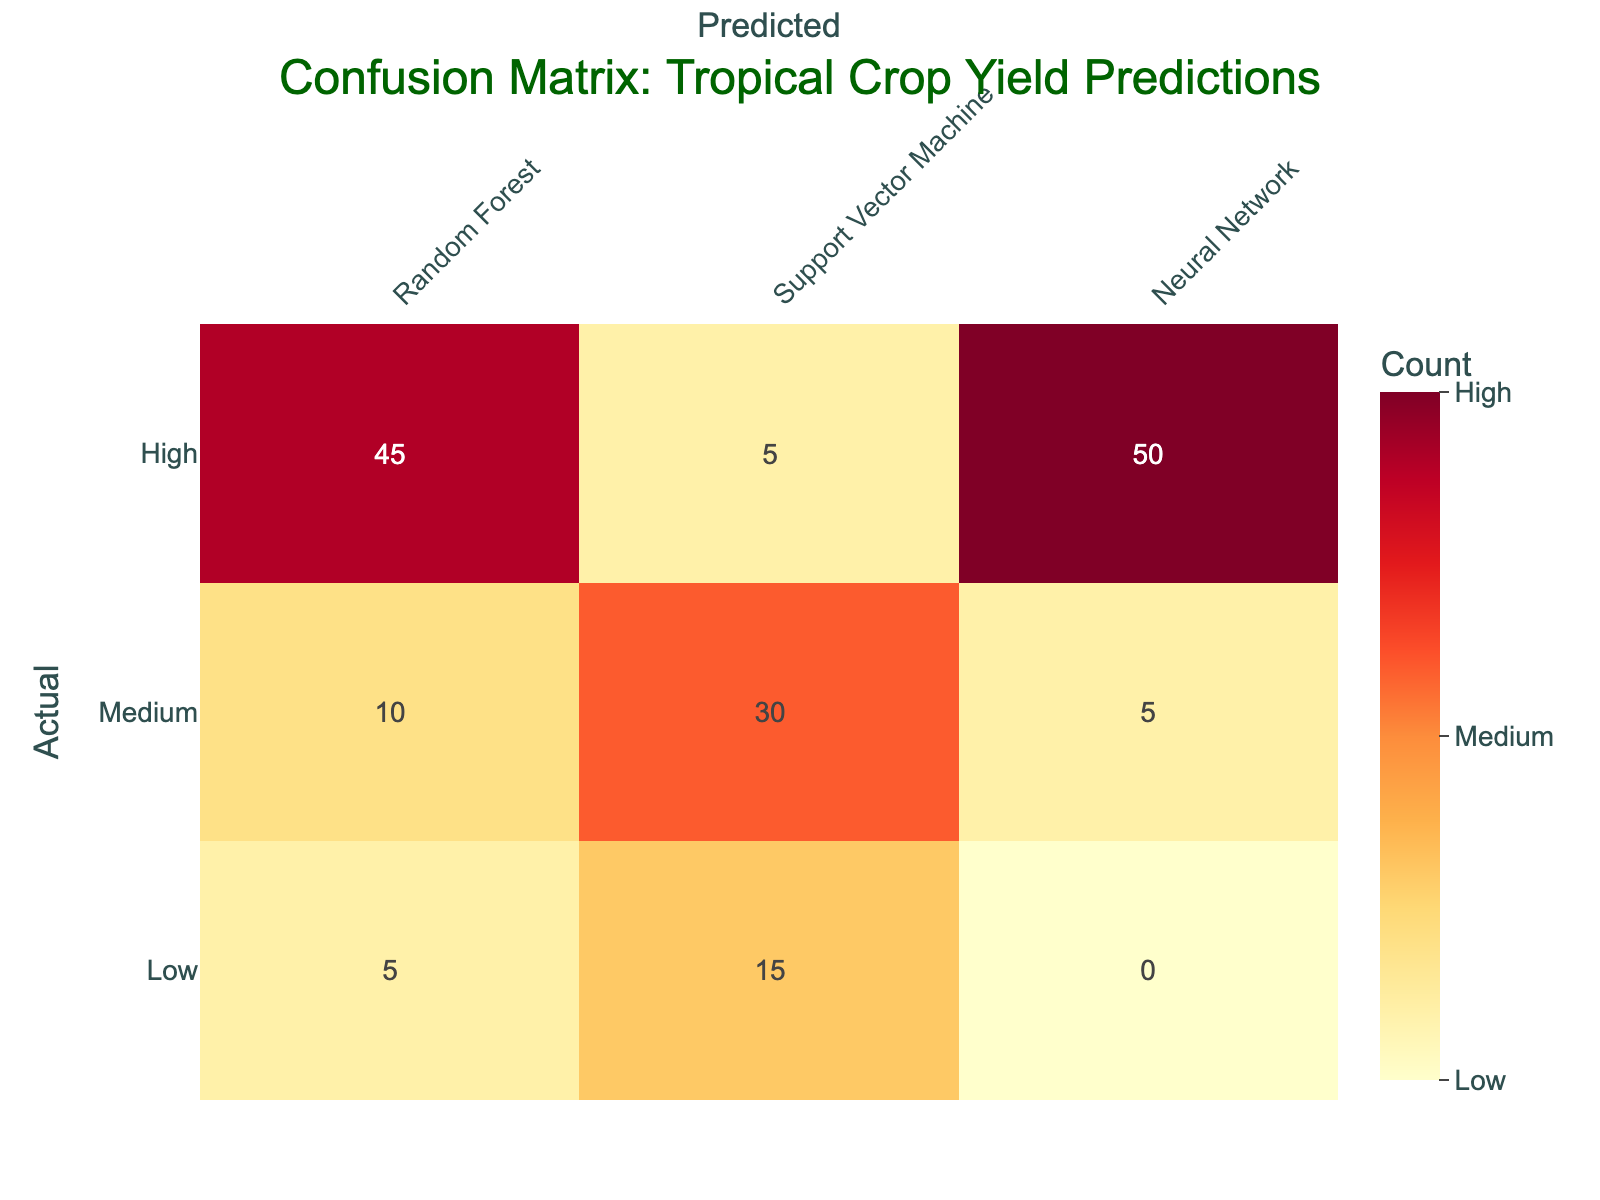What is the number of actual high yield crops predicted as high by the Random Forest model? In the table, under the column for Random Forest and the row for actual high yield, the value is 45.
Answer: 45 What is the total number of actual medium yield crops predicted as low across all models? In the row for actual medium yield, the values for all models are 10 (Random Forest) + 30 (Support Vector Machine) + 5 (Neural Network). Adding these gives 0, because the model predicted none of the medium yields as low.
Answer: 0 How many actual low yield crops were predicted as high by the Neural Network? Looking at the table, under the Neural Network column and actual low yield row, the value is 0.
Answer: 0 What percentage of the actual high yield crops were correctly predicted as high by the Support Vector Machine? The correct predictions for high yield by Support Vector Machine are 5, and the total actual high yield crops is 45. To find the percentage, we calculate (5 / 45) * 100, which equals approximately 11.1%.
Answer: 11.1% Is it true that the Neural Network model predicted more high yield crops than the Support Vector Machine model? From the table, the Neural Network predicted 50 high yield crops while the Support Vector Machine predicted 5 high yield crops. Therefore, it is true that the Neural Network predicted more.
Answer: Yes What is the difference in predictions of actual low yield crops between the Random Forest and Support Vector Machine models? The Random Forest model predicted 5 actual low yield crops and the Support Vector Machine predicted 15. The difference is calculated as 15 - 5 = 10.
Answer: 10 How many total predictions were made for actual medium yield crops that were predicted incorrectly? The total incorrect predictions for medium yield crops can be calculated from the values: Non-correct predictions from Random Forest = 10 + Low predictions = 5. Total = 10 + 5 = 15.
Answer: 15 What is the total count of predicted low yield crops across all models? To find this, we sum the low yield predictions from all models: 5 (Random Forest) + 15 (Support Vector Machine) + 0 (Neural Network) = 20.
Answer: 20 How many actual medium yield crops were predicted as high by the Neural Network? In the row for actual medium yield and the column for Neural Network, the value is 5.
Answer: 5 